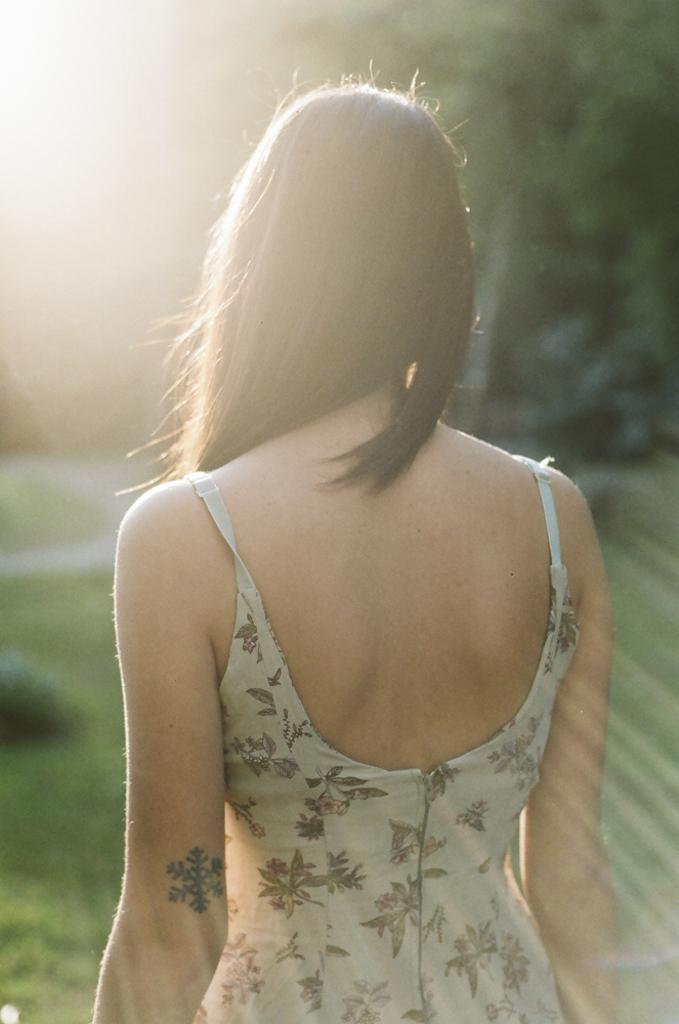What is the main subject in the image? There is a person standing in the image. How much of the person is visible in the image? The person is partially cut off at the bottom of the image. What type of terrain is visible in the image? There is grass in the image, which is also partially cut off. Can you describe the background of the image? The background of the image is blurred. What type of army uniform can be seen on the person in the image? There is no army uniform visible in the image, as it only features a person standing in a partially cut-off position with a blurred background. 